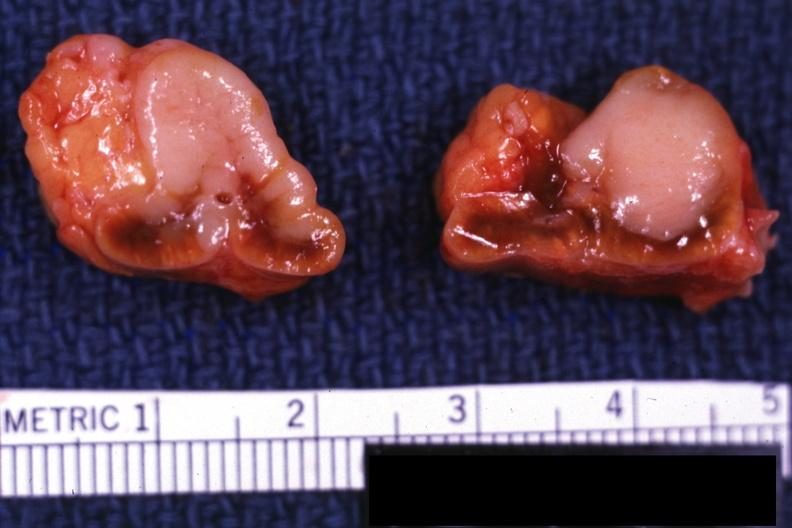where does this belong to?
Answer the question using a single word or phrase. Endocrine system 